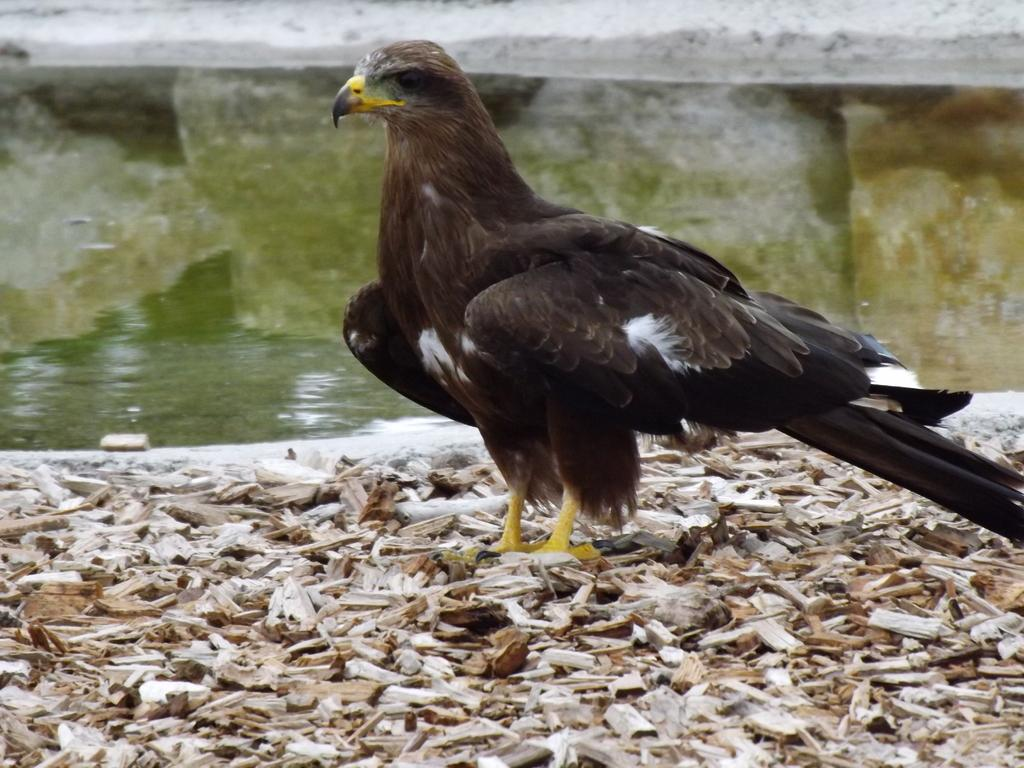What animal can be seen in the picture? There is an eagle in the picture. What natural element is visible in the picture? There is water visible in the picture. What does the water in the picture reflect? The water reflects rocks in the picture. What type of hair can be seen on the eagle in the picture? There is no hair visible on the eagle in the picture, as eagles have feathers, not hair. 